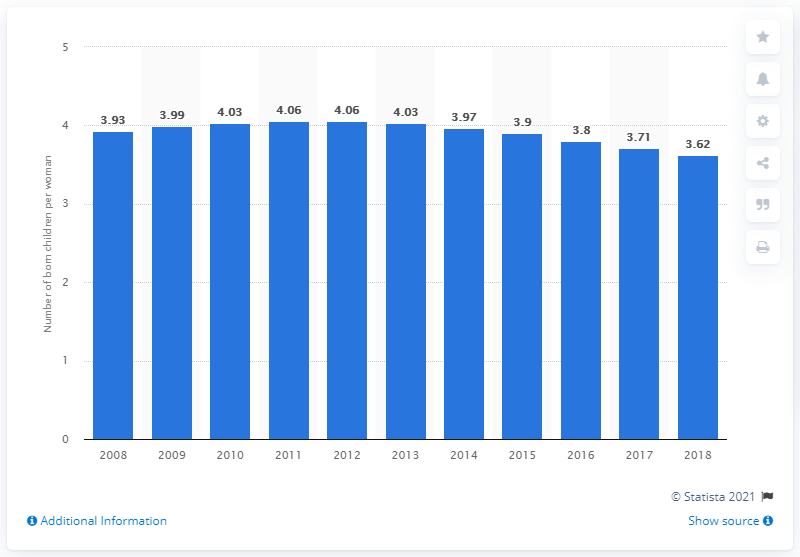Outline some significant characteristics in this image. In 2018, the fertility rate in Zimbabwe was 3.62. 